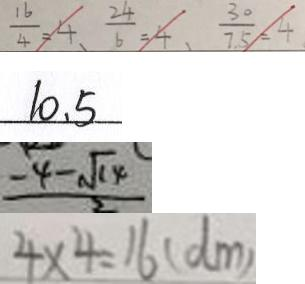<formula> <loc_0><loc_0><loc_500><loc_500>\frac { 1 6 } { 4 } = 4 、 \frac { 2 4 } { 6 } = 4 、 \frac { 3 0 } { 7 . 5 } = 4 
 1 0 . 5 
 \frac { - 4 - \sqrt { 1 4 } } { 2 } 
 4 \times 4 = 1 6 ( d m )</formula> 